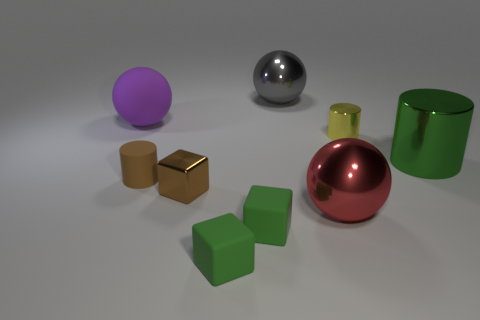Is the number of tiny things greater than the number of red metal spheres? After examining the image, it appears that the number of small objects, which include the cubes and the small spheres, exceeds the count of red metal spheres. Specifically, there are three green cubes, two brown cubes, and two small spheres of varying colors, totaling seven small objects. In contrast, there is only one large red metal sphere. 